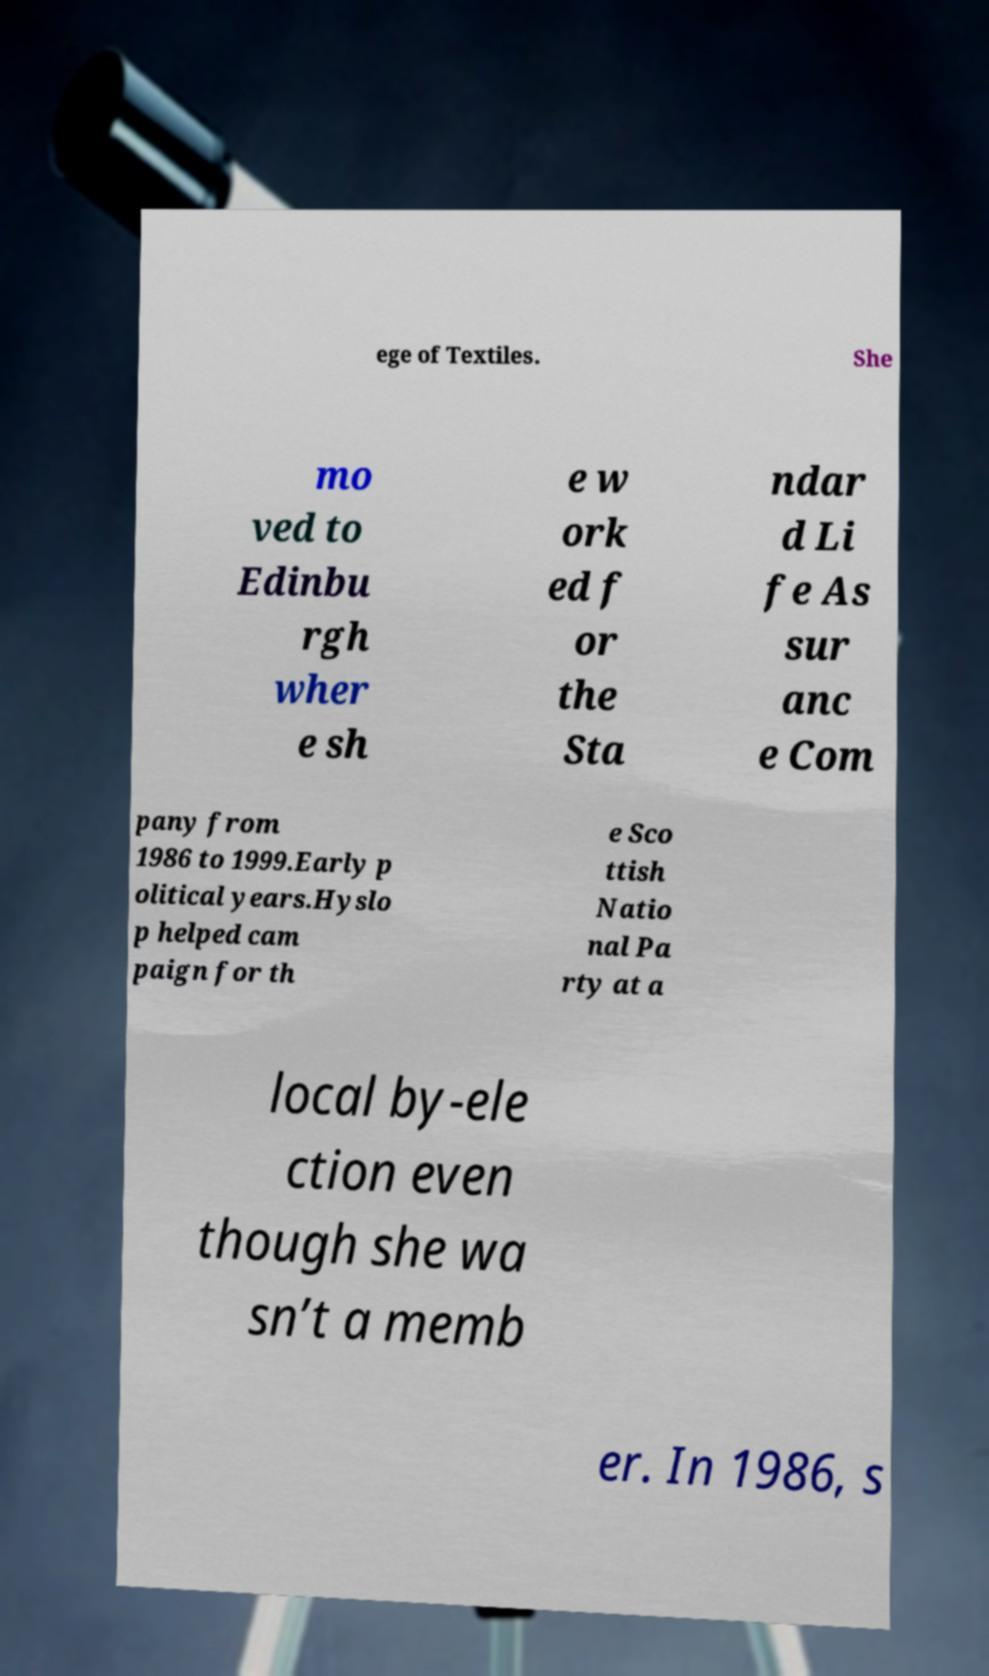Could you assist in decoding the text presented in this image and type it out clearly? ege of Textiles. She mo ved to Edinbu rgh wher e sh e w ork ed f or the Sta ndar d Li fe As sur anc e Com pany from 1986 to 1999.Early p olitical years.Hyslo p helped cam paign for th e Sco ttish Natio nal Pa rty at a local by-ele ction even though she wa sn’t a memb er. In 1986, s 